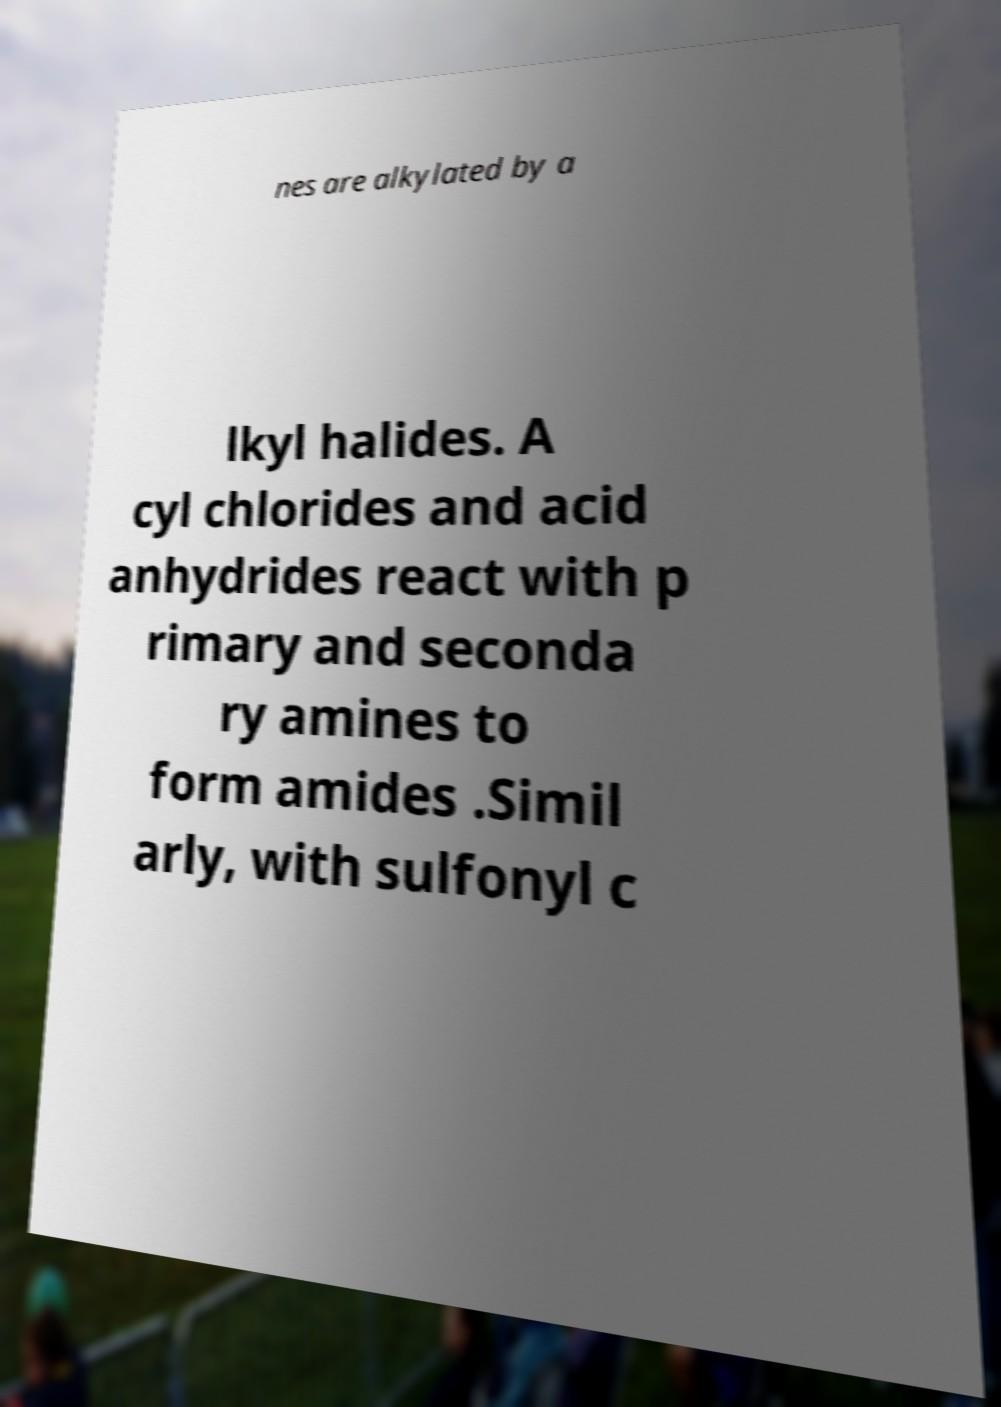Could you extract and type out the text from this image? nes are alkylated by a lkyl halides. A cyl chlorides and acid anhydrides react with p rimary and seconda ry amines to form amides .Simil arly, with sulfonyl c 